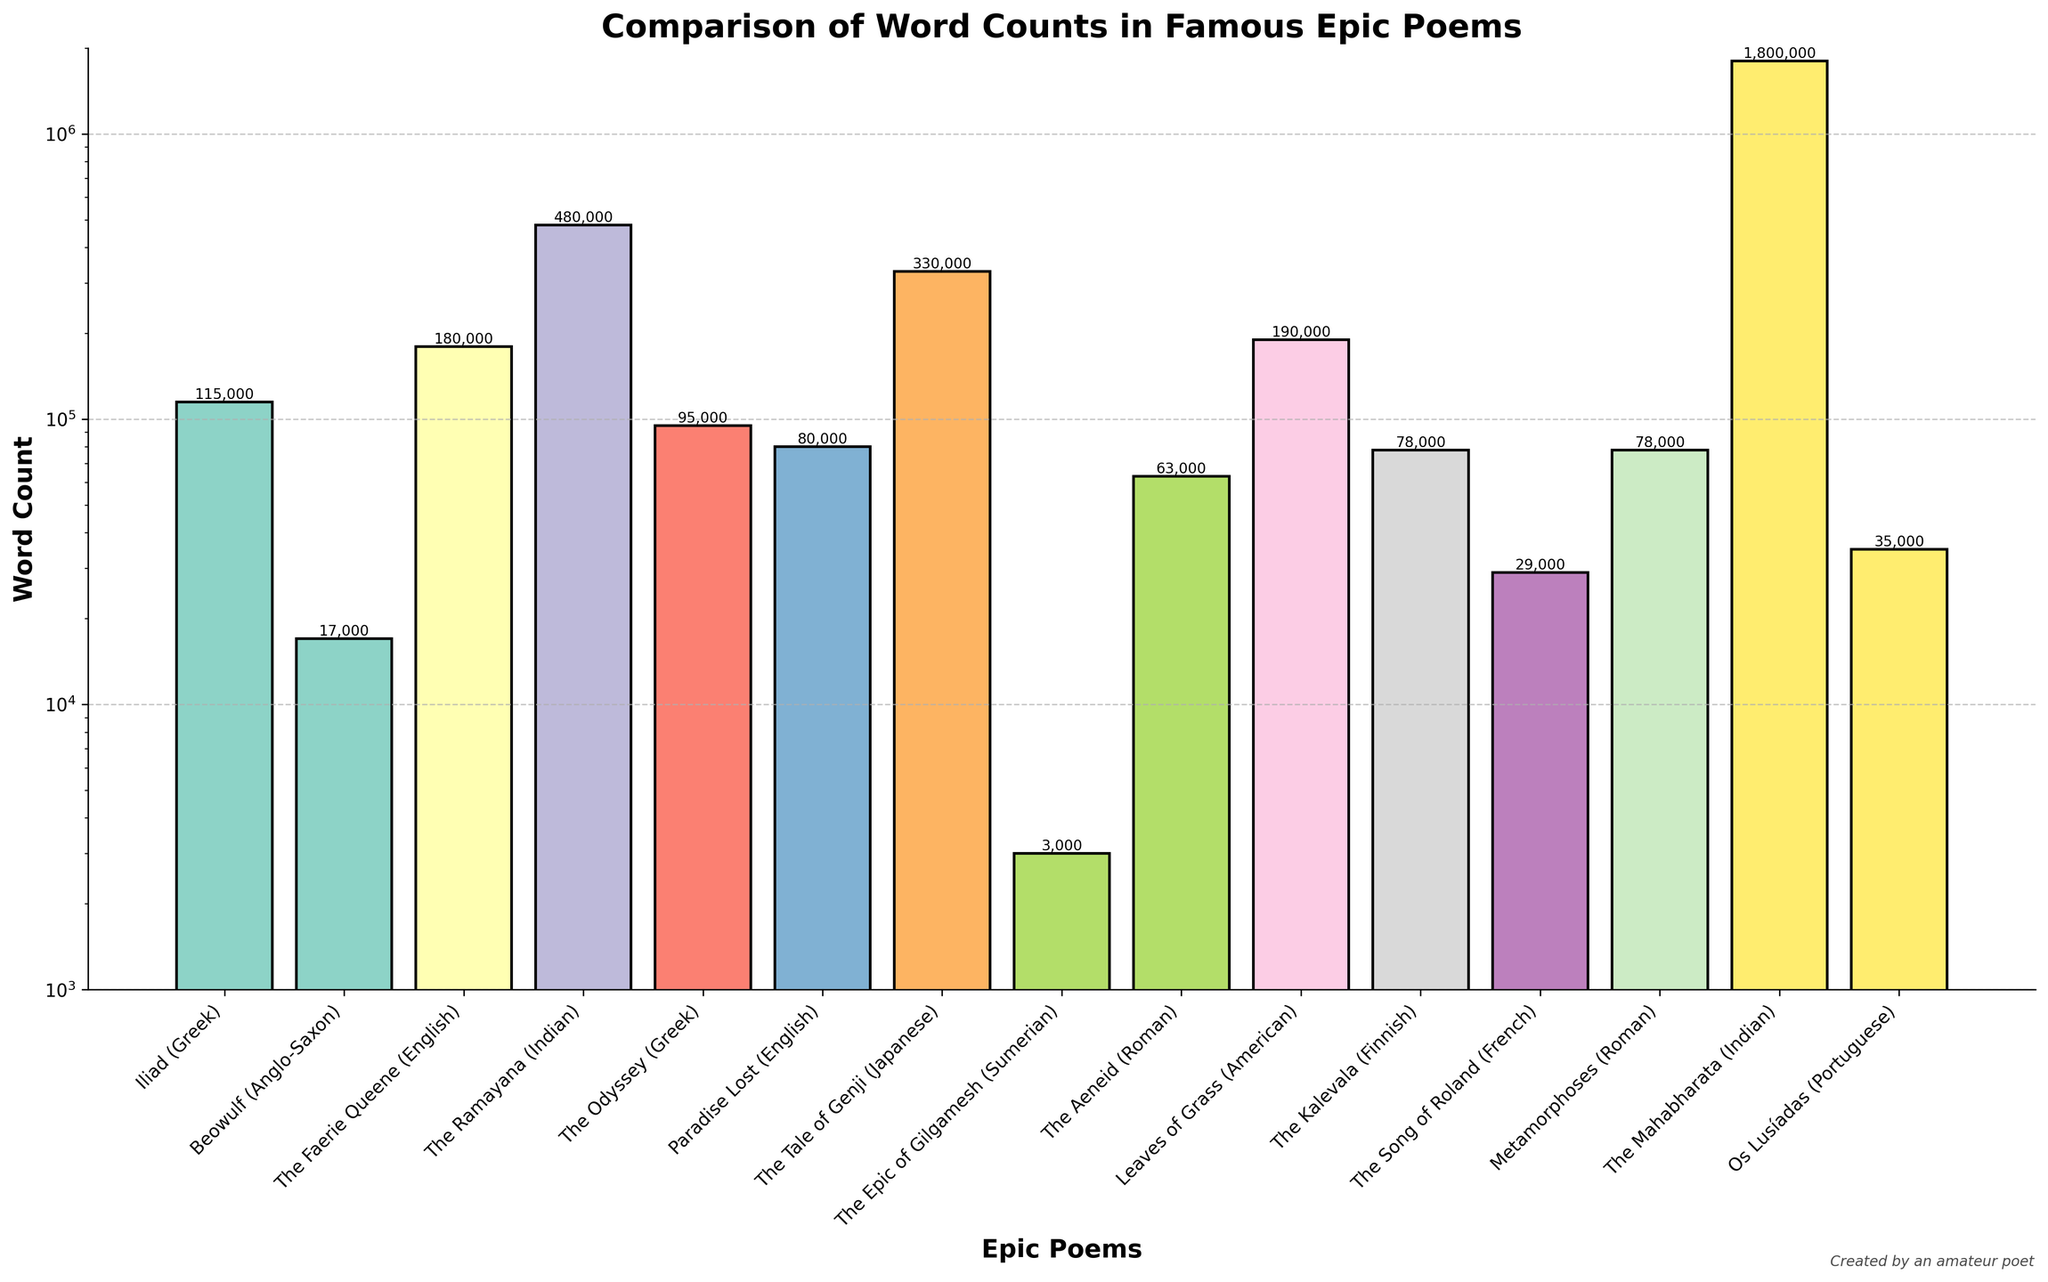How many times longer is The Mahabharata compared to The Iliad? To find this, divide the word count of The Mahabharata (1,800,000) by that of The Iliad (115,000). 1,800,000 / 115,000 ≈ 15.65
Answer: 15.65 times Which epic poem has the shortest word count? Look for the bar with the smallest height. The Epic of Gilgamesh has the shortest word count at 3,000.
Answer: The Epic of Gilgamesh Between The Ramayana and The Faerie Queene, which one has a higher word count and by how much? Compare the heights of the bars for these two epics. The Ramayana has 480,000 words, while The Faerie Queene has 180,000 words. Subtract to find the difference: 480,000 - 180,000 = 300,000.
Answer: The Ramayana by 300,000 words What is the average word count of the three epic poems with the lowest word counts? Identify the three smallest bars: The Epic of Gilgamesh (3,000), Beowulf (17,000), and The Song of Roland (29,000). Sum these: 3,000 + 17,000 + 29,000 = 49,000. Divide by 3: 49,000 / 3 ≈ 16,333.33.
Answer: 16,333.33 Which epic poem has a word count closest to the median value of all the epic poems listed? List the word counts in ascending order and find the median. Middle values are for The Faerie Queene (180,000) and The Tale of Genji (330,000), so the median is (180,000 + 330,000) / 2 = 255,000. The Tale of Genji at 330,000 is closest.
Answer: The Tale of Genji Which two epic poems are closest in word count, and what is their difference? Compare word counts and find the smallest difference: Paradise Lost (80,000) and The Kalevala (78,000). Subtract to find the difference: 80,000 - 78,000 = 2,000.
Answer: Paradise Lost and The Kalevala with a 2,000 difference How much longer is Leaves of Grass compared to Os Lusíadas? Compare their word counts: Leaves of Grass (190,000) and Os Lusíadas (35,000). Subtract to find the difference: 190,000 - 35,000 = 155,000.
Answer: 155,000 words Visually, which epic poem corresponds to the tallest bar in the chart? The tallest bar should visually represent the epic with the highest word count. The Mahabharata, which has 1,800,000 words, is the tallest bar.
Answer: The Mahabharata Which epic poems have word counts that fall between 50,000 and 100,000? Identify the bars within this range: The Odyssey (95,000), Paradise Lost (80,000), The Kalevala (78,000), and Metamorphoses (78,000).
Answer: The Odyssey, Paradise Lost, The Kalevala, Metamorphoses How does the word count of The Aeneid compare to that of Beowulf? Compare their word counts: The Aeneid (63,000) and Beowulf (17,000). The Aeneid has more words.
Answer: The Aeneid has more words 